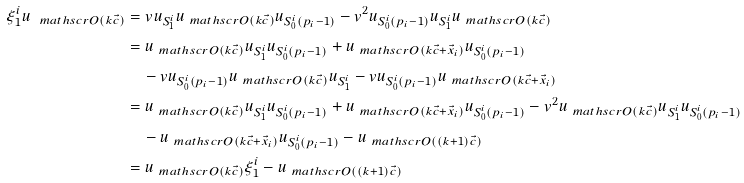Convert formula to latex. <formula><loc_0><loc_0><loc_500><loc_500>\xi ^ { i } _ { 1 } u _ { \ m a t h s c r { O } ( k \vec { c } ) } & = v u _ { S ^ { i } _ { 1 } } u _ { \ m a t h s c r { O } ( k \vec { c } ) } u _ { S ^ { i } _ { 0 } ( p _ { i } - 1 ) } - v ^ { 2 } u _ { S ^ { i } _ { 0 } ( p _ { i } - 1 ) } u _ { S ^ { i } _ { 1 } } u _ { \ m a t h s c r { O } ( k \vec { c } ) } \\ & = u _ { \ m a t h s c r { O } ( k \vec { c } ) } u _ { S ^ { i } _ { 1 } } u _ { S ^ { i } _ { 0 } ( p _ { i } - 1 ) } + u _ { \ m a t h s c r { O } ( k \vec { c } + \vec { x } _ { i } ) } u _ { S ^ { i } _ { 0 } ( p _ { i } - 1 ) } \\ & \quad - v u _ { S ^ { i } _ { 0 } ( p _ { i } - 1 ) } u _ { \ m a t h s c r { O } ( k \vec { c } ) } u _ { S ^ { i } _ { 1 } } - v u _ { S ^ { i } _ { 0 } ( p _ { i } - 1 ) } u _ { \ m a t h s c r { O } ( k \vec { c } + \vec { x } _ { i } ) } \\ & = u _ { \ m a t h s c r { O } ( k \vec { c } ) } u _ { S ^ { i } _ { 1 } } u _ { S ^ { i } _ { 0 } ( p _ { i } - 1 ) } + u _ { \ m a t h s c r { O } ( k \vec { c } + \vec { x } _ { i } ) } u _ { S ^ { i } _ { 0 } ( p _ { i } - 1 ) } - v ^ { 2 } u _ { \ m a t h s c r { O } ( k \vec { c } ) } u _ { S ^ { i } _ { 1 } } u _ { S ^ { i } _ { 0 } ( p _ { i } - 1 ) } \\ & \quad - u _ { \ m a t h s c r { O } ( k \vec { c } + \vec { x } _ { i } ) } u _ { S ^ { i } _ { 0 } ( p _ { i } - 1 ) } - u _ { \ m a t h s c r { O } ( ( k + 1 ) \vec { c } ) } \\ & = u _ { \ m a t h s c r { O } ( k \vec { c } ) } \xi ^ { i } _ { 1 } - u _ { \ m a t h s c r { O } ( ( k + 1 ) \vec { c } ) }</formula> 